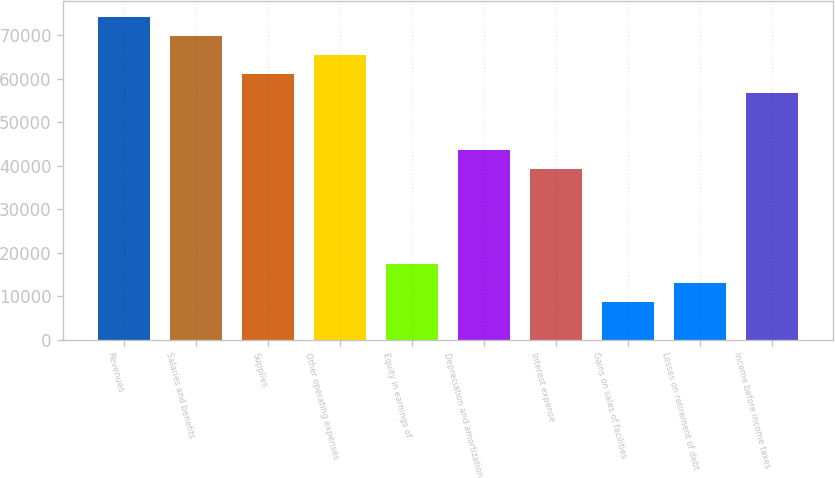Convert chart. <chart><loc_0><loc_0><loc_500><loc_500><bar_chart><fcel>Revenues<fcel>Salaries and benefits<fcel>Supplies<fcel>Other operating expenses<fcel>Equity in earnings of<fcel>Depreciation and amortization<fcel>Interest expense<fcel>Gains on sales of facilities<fcel>Losses on retirement of debt<fcel>Income before income taxes<nl><fcel>74139.6<fcel>69778.9<fcel>61057.2<fcel>65418<fcel>17449.2<fcel>43614<fcel>39253.2<fcel>8727.57<fcel>13088.4<fcel>56696.4<nl></chart> 